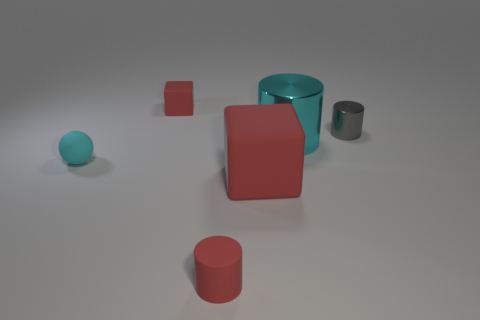The small thing on the left side of the tiny rubber block that is behind the large cyan cylinder behind the tiny cyan object is what color?
Your answer should be compact. Cyan. What number of other objects are there of the same material as the tiny red cylinder?
Give a very brief answer. 3. There is a cyan object in front of the large cyan cylinder; is its shape the same as the big red thing?
Give a very brief answer. No. What number of small things are cyan rubber things or shiny objects?
Make the answer very short. 2. Are there an equal number of matte blocks left of the large red object and things behind the red matte cylinder?
Ensure brevity in your answer.  No. What number of other things are there of the same color as the matte sphere?
Your answer should be compact. 1. There is a large matte block; is it the same color as the metallic object that is left of the gray object?
Offer a very short reply. No. How many gray things are tiny rubber blocks or rubber blocks?
Provide a short and direct response. 0. Are there the same number of small gray objects on the right side of the tiny cyan matte ball and large red matte things?
Your answer should be compact. Yes. Is there any other thing that has the same size as the cyan metal thing?
Keep it short and to the point. Yes. 